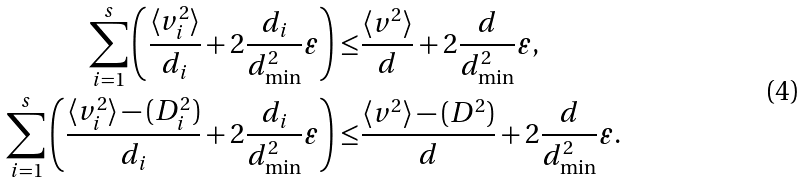<formula> <loc_0><loc_0><loc_500><loc_500>\sum _ { i = 1 } ^ { s } \left ( \frac { \langle v _ { i } ^ { 2 } \rangle } { d _ { i } } + 2 \frac { d _ { i } } { d _ { \min } ^ { 2 } } \varepsilon \right ) \leq & \frac { \langle v ^ { 2 } \rangle } { d } + 2 \frac { d } { d _ { \min } ^ { 2 } } \varepsilon , \\ \sum _ { i = 1 } ^ { s } \left ( \frac { \langle v _ { i } ^ { 2 } \rangle - ( D _ { i } ^ { 2 } ) } { d _ { i } } + 2 \frac { d _ { i } } { d _ { \min } ^ { 2 } } \varepsilon \right ) \leq & \frac { \langle v ^ { 2 } \rangle - ( D ^ { 2 } ) } { d } + 2 \frac { d } { d _ { \min } ^ { 2 } } \varepsilon .</formula> 